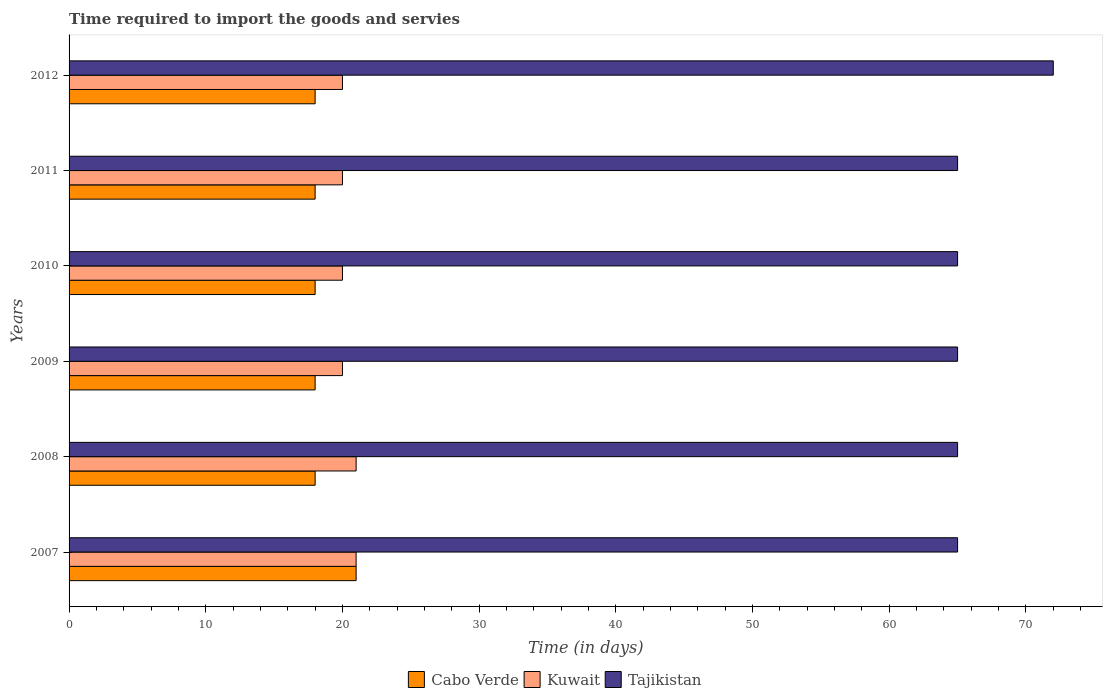How many groups of bars are there?
Provide a short and direct response. 6. Are the number of bars per tick equal to the number of legend labels?
Ensure brevity in your answer.  Yes. Are the number of bars on each tick of the Y-axis equal?
Your response must be concise. Yes. How many bars are there on the 3rd tick from the top?
Provide a short and direct response. 3. What is the label of the 3rd group of bars from the top?
Keep it short and to the point. 2010. In how many cases, is the number of bars for a given year not equal to the number of legend labels?
Make the answer very short. 0. What is the number of days required to import the goods and services in Kuwait in 2012?
Offer a very short reply. 20. Across all years, what is the maximum number of days required to import the goods and services in Kuwait?
Give a very brief answer. 21. Across all years, what is the minimum number of days required to import the goods and services in Tajikistan?
Offer a very short reply. 65. In which year was the number of days required to import the goods and services in Tajikistan maximum?
Give a very brief answer. 2012. What is the total number of days required to import the goods and services in Tajikistan in the graph?
Offer a terse response. 397. What is the difference between the number of days required to import the goods and services in Cabo Verde in 2007 and that in 2011?
Provide a short and direct response. 3. What is the difference between the number of days required to import the goods and services in Cabo Verde in 2009 and the number of days required to import the goods and services in Kuwait in 2011?
Your answer should be very brief. -2. What is the average number of days required to import the goods and services in Kuwait per year?
Make the answer very short. 20.33. In the year 2012, what is the difference between the number of days required to import the goods and services in Tajikistan and number of days required to import the goods and services in Cabo Verde?
Your answer should be very brief. 54. What is the ratio of the number of days required to import the goods and services in Cabo Verde in 2007 to that in 2011?
Your answer should be very brief. 1.17. Is the difference between the number of days required to import the goods and services in Tajikistan in 2008 and 2011 greater than the difference between the number of days required to import the goods and services in Cabo Verde in 2008 and 2011?
Your response must be concise. No. What is the difference between the highest and the second highest number of days required to import the goods and services in Tajikistan?
Provide a short and direct response. 7. What is the difference between the highest and the lowest number of days required to import the goods and services in Cabo Verde?
Offer a terse response. 3. In how many years, is the number of days required to import the goods and services in Tajikistan greater than the average number of days required to import the goods and services in Tajikistan taken over all years?
Provide a succinct answer. 1. Is the sum of the number of days required to import the goods and services in Tajikistan in 2007 and 2011 greater than the maximum number of days required to import the goods and services in Cabo Verde across all years?
Offer a very short reply. Yes. What does the 1st bar from the top in 2012 represents?
Your answer should be very brief. Tajikistan. What does the 3rd bar from the bottom in 2010 represents?
Keep it short and to the point. Tajikistan. Is it the case that in every year, the sum of the number of days required to import the goods and services in Kuwait and number of days required to import the goods and services in Cabo Verde is greater than the number of days required to import the goods and services in Tajikistan?
Give a very brief answer. No. How many bars are there?
Your answer should be very brief. 18. How many years are there in the graph?
Offer a very short reply. 6. What is the difference between two consecutive major ticks on the X-axis?
Provide a short and direct response. 10. Does the graph contain any zero values?
Your response must be concise. No. Does the graph contain grids?
Your answer should be compact. No. How many legend labels are there?
Offer a terse response. 3. What is the title of the graph?
Your answer should be compact. Time required to import the goods and servies. What is the label or title of the X-axis?
Your response must be concise. Time (in days). What is the Time (in days) in Cabo Verde in 2007?
Ensure brevity in your answer.  21. What is the Time (in days) of Tajikistan in 2007?
Ensure brevity in your answer.  65. What is the Time (in days) in Kuwait in 2008?
Ensure brevity in your answer.  21. What is the Time (in days) of Tajikistan in 2008?
Give a very brief answer. 65. What is the Time (in days) in Cabo Verde in 2009?
Your answer should be very brief. 18. What is the Time (in days) in Cabo Verde in 2010?
Your answer should be compact. 18. What is the Time (in days) in Tajikistan in 2010?
Provide a short and direct response. 65. What is the Time (in days) of Tajikistan in 2011?
Provide a short and direct response. 65. What is the Time (in days) of Cabo Verde in 2012?
Ensure brevity in your answer.  18. Across all years, what is the maximum Time (in days) in Kuwait?
Make the answer very short. 21. Across all years, what is the maximum Time (in days) of Tajikistan?
Give a very brief answer. 72. Across all years, what is the minimum Time (in days) of Cabo Verde?
Keep it short and to the point. 18. Across all years, what is the minimum Time (in days) of Kuwait?
Offer a very short reply. 20. Across all years, what is the minimum Time (in days) of Tajikistan?
Provide a short and direct response. 65. What is the total Time (in days) of Cabo Verde in the graph?
Your response must be concise. 111. What is the total Time (in days) of Kuwait in the graph?
Your answer should be compact. 122. What is the total Time (in days) in Tajikistan in the graph?
Keep it short and to the point. 397. What is the difference between the Time (in days) in Kuwait in 2007 and that in 2008?
Make the answer very short. 0. What is the difference between the Time (in days) in Tajikistan in 2007 and that in 2008?
Keep it short and to the point. 0. What is the difference between the Time (in days) in Cabo Verde in 2007 and that in 2009?
Your answer should be compact. 3. What is the difference between the Time (in days) of Kuwait in 2007 and that in 2009?
Give a very brief answer. 1. What is the difference between the Time (in days) in Cabo Verde in 2007 and that in 2010?
Your response must be concise. 3. What is the difference between the Time (in days) of Kuwait in 2007 and that in 2010?
Ensure brevity in your answer.  1. What is the difference between the Time (in days) of Cabo Verde in 2007 and that in 2011?
Your response must be concise. 3. What is the difference between the Time (in days) of Kuwait in 2007 and that in 2011?
Your response must be concise. 1. What is the difference between the Time (in days) in Tajikistan in 2007 and that in 2012?
Keep it short and to the point. -7. What is the difference between the Time (in days) in Cabo Verde in 2008 and that in 2009?
Provide a succinct answer. 0. What is the difference between the Time (in days) of Kuwait in 2008 and that in 2009?
Give a very brief answer. 1. What is the difference between the Time (in days) of Tajikistan in 2008 and that in 2009?
Your answer should be very brief. 0. What is the difference between the Time (in days) in Cabo Verde in 2008 and that in 2010?
Make the answer very short. 0. What is the difference between the Time (in days) in Tajikistan in 2008 and that in 2010?
Your answer should be compact. 0. What is the difference between the Time (in days) in Cabo Verde in 2008 and that in 2011?
Keep it short and to the point. 0. What is the difference between the Time (in days) in Kuwait in 2008 and that in 2011?
Your answer should be very brief. 1. What is the difference between the Time (in days) of Tajikistan in 2008 and that in 2011?
Your response must be concise. 0. What is the difference between the Time (in days) in Kuwait in 2008 and that in 2012?
Your answer should be compact. 1. What is the difference between the Time (in days) of Cabo Verde in 2009 and that in 2010?
Ensure brevity in your answer.  0. What is the difference between the Time (in days) of Tajikistan in 2009 and that in 2010?
Your answer should be very brief. 0. What is the difference between the Time (in days) in Cabo Verde in 2009 and that in 2011?
Give a very brief answer. 0. What is the difference between the Time (in days) of Kuwait in 2009 and that in 2011?
Ensure brevity in your answer.  0. What is the difference between the Time (in days) in Kuwait in 2009 and that in 2012?
Offer a terse response. 0. What is the difference between the Time (in days) in Cabo Verde in 2010 and that in 2011?
Your response must be concise. 0. What is the difference between the Time (in days) of Kuwait in 2010 and that in 2011?
Offer a terse response. 0. What is the difference between the Time (in days) of Cabo Verde in 2007 and the Time (in days) of Tajikistan in 2008?
Provide a short and direct response. -44. What is the difference between the Time (in days) of Kuwait in 2007 and the Time (in days) of Tajikistan in 2008?
Ensure brevity in your answer.  -44. What is the difference between the Time (in days) in Cabo Verde in 2007 and the Time (in days) in Tajikistan in 2009?
Your response must be concise. -44. What is the difference between the Time (in days) in Kuwait in 2007 and the Time (in days) in Tajikistan in 2009?
Offer a very short reply. -44. What is the difference between the Time (in days) of Cabo Verde in 2007 and the Time (in days) of Tajikistan in 2010?
Offer a terse response. -44. What is the difference between the Time (in days) of Kuwait in 2007 and the Time (in days) of Tajikistan in 2010?
Ensure brevity in your answer.  -44. What is the difference between the Time (in days) in Cabo Verde in 2007 and the Time (in days) in Kuwait in 2011?
Provide a succinct answer. 1. What is the difference between the Time (in days) of Cabo Verde in 2007 and the Time (in days) of Tajikistan in 2011?
Make the answer very short. -44. What is the difference between the Time (in days) in Kuwait in 2007 and the Time (in days) in Tajikistan in 2011?
Your answer should be compact. -44. What is the difference between the Time (in days) of Cabo Verde in 2007 and the Time (in days) of Kuwait in 2012?
Ensure brevity in your answer.  1. What is the difference between the Time (in days) in Cabo Verde in 2007 and the Time (in days) in Tajikistan in 2012?
Make the answer very short. -51. What is the difference between the Time (in days) of Kuwait in 2007 and the Time (in days) of Tajikistan in 2012?
Your response must be concise. -51. What is the difference between the Time (in days) of Cabo Verde in 2008 and the Time (in days) of Tajikistan in 2009?
Your answer should be very brief. -47. What is the difference between the Time (in days) in Kuwait in 2008 and the Time (in days) in Tajikistan in 2009?
Ensure brevity in your answer.  -44. What is the difference between the Time (in days) of Cabo Verde in 2008 and the Time (in days) of Tajikistan in 2010?
Offer a terse response. -47. What is the difference between the Time (in days) of Kuwait in 2008 and the Time (in days) of Tajikistan in 2010?
Offer a very short reply. -44. What is the difference between the Time (in days) in Cabo Verde in 2008 and the Time (in days) in Tajikistan in 2011?
Keep it short and to the point. -47. What is the difference between the Time (in days) in Kuwait in 2008 and the Time (in days) in Tajikistan in 2011?
Offer a terse response. -44. What is the difference between the Time (in days) of Cabo Verde in 2008 and the Time (in days) of Kuwait in 2012?
Make the answer very short. -2. What is the difference between the Time (in days) in Cabo Verde in 2008 and the Time (in days) in Tajikistan in 2012?
Ensure brevity in your answer.  -54. What is the difference between the Time (in days) in Kuwait in 2008 and the Time (in days) in Tajikistan in 2012?
Provide a short and direct response. -51. What is the difference between the Time (in days) of Cabo Verde in 2009 and the Time (in days) of Kuwait in 2010?
Your answer should be very brief. -2. What is the difference between the Time (in days) of Cabo Verde in 2009 and the Time (in days) of Tajikistan in 2010?
Offer a very short reply. -47. What is the difference between the Time (in days) in Kuwait in 2009 and the Time (in days) in Tajikistan in 2010?
Your answer should be very brief. -45. What is the difference between the Time (in days) in Cabo Verde in 2009 and the Time (in days) in Kuwait in 2011?
Your answer should be compact. -2. What is the difference between the Time (in days) of Cabo Verde in 2009 and the Time (in days) of Tajikistan in 2011?
Offer a very short reply. -47. What is the difference between the Time (in days) of Kuwait in 2009 and the Time (in days) of Tajikistan in 2011?
Your response must be concise. -45. What is the difference between the Time (in days) of Cabo Verde in 2009 and the Time (in days) of Kuwait in 2012?
Your answer should be very brief. -2. What is the difference between the Time (in days) of Cabo Verde in 2009 and the Time (in days) of Tajikistan in 2012?
Make the answer very short. -54. What is the difference between the Time (in days) in Kuwait in 2009 and the Time (in days) in Tajikistan in 2012?
Make the answer very short. -52. What is the difference between the Time (in days) of Cabo Verde in 2010 and the Time (in days) of Kuwait in 2011?
Provide a short and direct response. -2. What is the difference between the Time (in days) in Cabo Verde in 2010 and the Time (in days) in Tajikistan in 2011?
Offer a very short reply. -47. What is the difference between the Time (in days) in Kuwait in 2010 and the Time (in days) in Tajikistan in 2011?
Make the answer very short. -45. What is the difference between the Time (in days) of Cabo Verde in 2010 and the Time (in days) of Kuwait in 2012?
Provide a succinct answer. -2. What is the difference between the Time (in days) in Cabo Verde in 2010 and the Time (in days) in Tajikistan in 2012?
Offer a very short reply. -54. What is the difference between the Time (in days) of Kuwait in 2010 and the Time (in days) of Tajikistan in 2012?
Give a very brief answer. -52. What is the difference between the Time (in days) in Cabo Verde in 2011 and the Time (in days) in Tajikistan in 2012?
Your answer should be very brief. -54. What is the difference between the Time (in days) in Kuwait in 2011 and the Time (in days) in Tajikistan in 2012?
Offer a very short reply. -52. What is the average Time (in days) in Kuwait per year?
Give a very brief answer. 20.33. What is the average Time (in days) in Tajikistan per year?
Keep it short and to the point. 66.17. In the year 2007, what is the difference between the Time (in days) of Cabo Verde and Time (in days) of Kuwait?
Provide a succinct answer. 0. In the year 2007, what is the difference between the Time (in days) of Cabo Verde and Time (in days) of Tajikistan?
Your response must be concise. -44. In the year 2007, what is the difference between the Time (in days) in Kuwait and Time (in days) in Tajikistan?
Give a very brief answer. -44. In the year 2008, what is the difference between the Time (in days) of Cabo Verde and Time (in days) of Kuwait?
Your answer should be very brief. -3. In the year 2008, what is the difference between the Time (in days) in Cabo Verde and Time (in days) in Tajikistan?
Provide a succinct answer. -47. In the year 2008, what is the difference between the Time (in days) in Kuwait and Time (in days) in Tajikistan?
Offer a very short reply. -44. In the year 2009, what is the difference between the Time (in days) in Cabo Verde and Time (in days) in Tajikistan?
Provide a short and direct response. -47. In the year 2009, what is the difference between the Time (in days) of Kuwait and Time (in days) of Tajikistan?
Provide a short and direct response. -45. In the year 2010, what is the difference between the Time (in days) in Cabo Verde and Time (in days) in Tajikistan?
Provide a short and direct response. -47. In the year 2010, what is the difference between the Time (in days) in Kuwait and Time (in days) in Tajikistan?
Make the answer very short. -45. In the year 2011, what is the difference between the Time (in days) in Cabo Verde and Time (in days) in Kuwait?
Make the answer very short. -2. In the year 2011, what is the difference between the Time (in days) of Cabo Verde and Time (in days) of Tajikistan?
Ensure brevity in your answer.  -47. In the year 2011, what is the difference between the Time (in days) of Kuwait and Time (in days) of Tajikistan?
Your answer should be very brief. -45. In the year 2012, what is the difference between the Time (in days) in Cabo Verde and Time (in days) in Tajikistan?
Offer a terse response. -54. In the year 2012, what is the difference between the Time (in days) of Kuwait and Time (in days) of Tajikistan?
Provide a succinct answer. -52. What is the ratio of the Time (in days) of Tajikistan in 2007 to that in 2008?
Provide a succinct answer. 1. What is the ratio of the Time (in days) in Kuwait in 2007 to that in 2010?
Provide a succinct answer. 1.05. What is the ratio of the Time (in days) of Tajikistan in 2007 to that in 2010?
Provide a short and direct response. 1. What is the ratio of the Time (in days) of Cabo Verde in 2007 to that in 2011?
Give a very brief answer. 1.17. What is the ratio of the Time (in days) in Kuwait in 2007 to that in 2011?
Keep it short and to the point. 1.05. What is the ratio of the Time (in days) in Kuwait in 2007 to that in 2012?
Ensure brevity in your answer.  1.05. What is the ratio of the Time (in days) of Tajikistan in 2007 to that in 2012?
Offer a very short reply. 0.9. What is the ratio of the Time (in days) in Kuwait in 2008 to that in 2009?
Provide a short and direct response. 1.05. What is the ratio of the Time (in days) in Tajikistan in 2008 to that in 2009?
Provide a succinct answer. 1. What is the ratio of the Time (in days) of Cabo Verde in 2008 to that in 2010?
Your answer should be compact. 1. What is the ratio of the Time (in days) in Kuwait in 2008 to that in 2011?
Provide a short and direct response. 1.05. What is the ratio of the Time (in days) of Tajikistan in 2008 to that in 2011?
Provide a succinct answer. 1. What is the ratio of the Time (in days) in Tajikistan in 2008 to that in 2012?
Your answer should be very brief. 0.9. What is the ratio of the Time (in days) in Cabo Verde in 2009 to that in 2010?
Your answer should be compact. 1. What is the ratio of the Time (in days) in Cabo Verde in 2009 to that in 2012?
Give a very brief answer. 1. What is the ratio of the Time (in days) in Kuwait in 2009 to that in 2012?
Make the answer very short. 1. What is the ratio of the Time (in days) in Tajikistan in 2009 to that in 2012?
Offer a very short reply. 0.9. What is the ratio of the Time (in days) of Cabo Verde in 2010 to that in 2011?
Offer a terse response. 1. What is the ratio of the Time (in days) of Tajikistan in 2010 to that in 2011?
Make the answer very short. 1. What is the ratio of the Time (in days) in Kuwait in 2010 to that in 2012?
Offer a very short reply. 1. What is the ratio of the Time (in days) in Tajikistan in 2010 to that in 2012?
Provide a short and direct response. 0.9. What is the ratio of the Time (in days) of Kuwait in 2011 to that in 2012?
Make the answer very short. 1. What is the ratio of the Time (in days) of Tajikistan in 2011 to that in 2012?
Make the answer very short. 0.9. What is the difference between the highest and the second highest Time (in days) in Kuwait?
Make the answer very short. 0. 